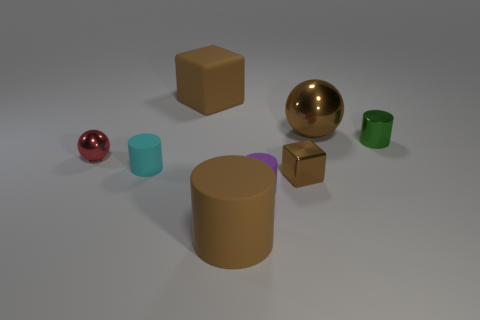Subtract all blue cubes. Subtract all yellow balls. How many cubes are left? 2 Add 2 small shiny balls. How many objects exist? 10 Subtract all spheres. How many objects are left? 6 Add 8 small yellow objects. How many small yellow objects exist? 8 Subtract 0 cyan cubes. How many objects are left? 8 Subtract all tiny cyan cylinders. Subtract all cylinders. How many objects are left? 3 Add 6 green things. How many green things are left? 7 